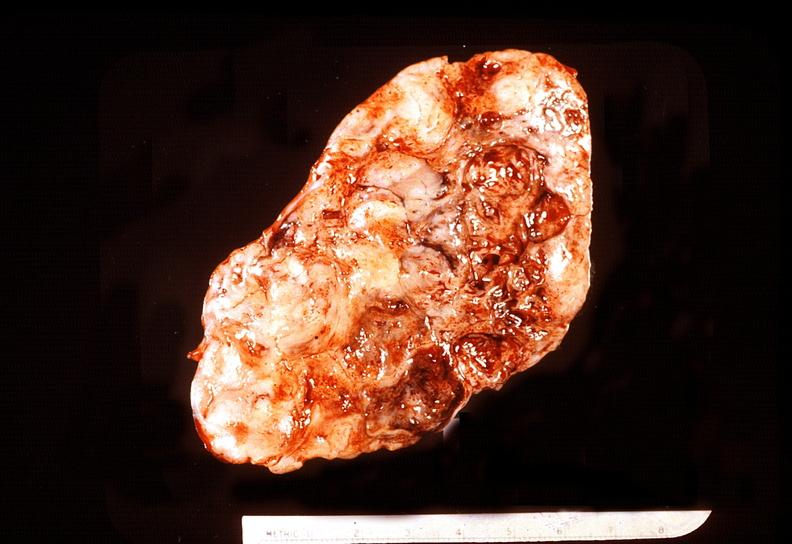s carcinoma present?
Answer the question using a single word or phrase. No 